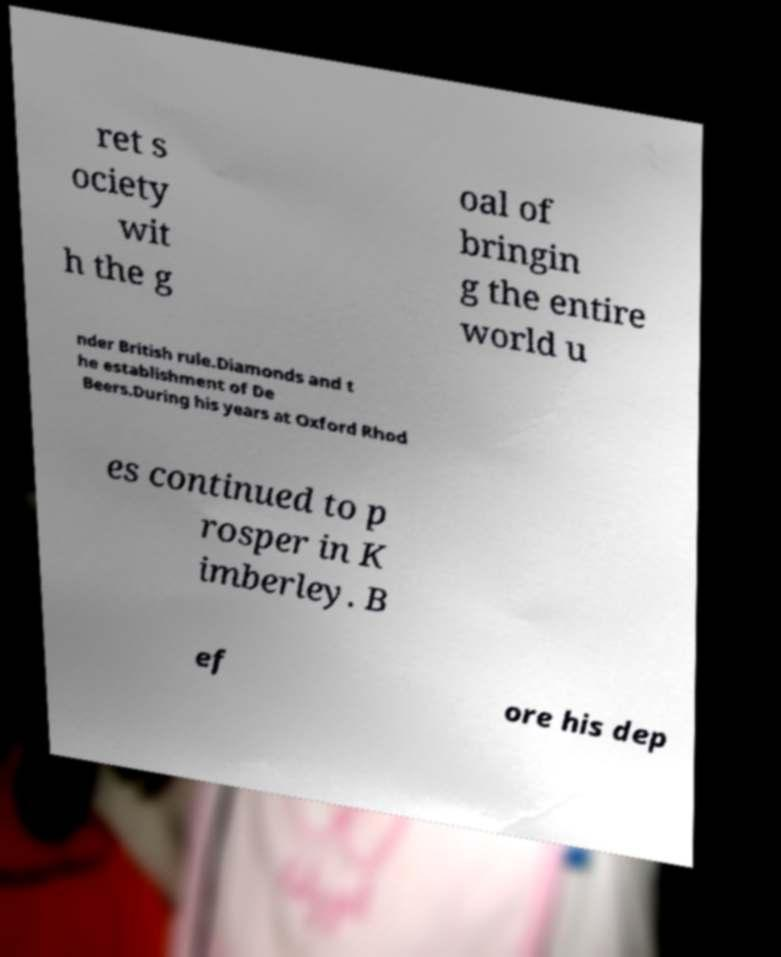Can you accurately transcribe the text from the provided image for me? ret s ociety wit h the g oal of bringin g the entire world u nder British rule.Diamonds and t he establishment of De Beers.During his years at Oxford Rhod es continued to p rosper in K imberley. B ef ore his dep 